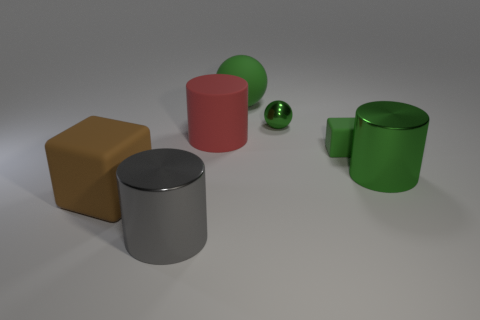There is a green cylinder that is behind the gray object; what material is it?
Ensure brevity in your answer.  Metal. How many things are small balls or things that are on the left side of the big rubber ball?
Your answer should be very brief. 4. There is a brown matte object that is the same size as the gray shiny cylinder; what is its shape?
Provide a short and direct response. Cube. How many shiny cylinders have the same color as the tiny matte block?
Your answer should be very brief. 1. Is the block behind the brown thing made of the same material as the large gray cylinder?
Keep it short and to the point. No. There is a gray thing; what shape is it?
Make the answer very short. Cylinder. What number of blue things are either big rubber cylinders or shiny balls?
Your answer should be compact. 0. What number of other things are there of the same material as the small block
Provide a short and direct response. 3. There is a large metallic object behind the gray shiny object; is it the same shape as the red object?
Provide a short and direct response. Yes. Are there any red metallic cylinders?
Provide a succinct answer. No. 